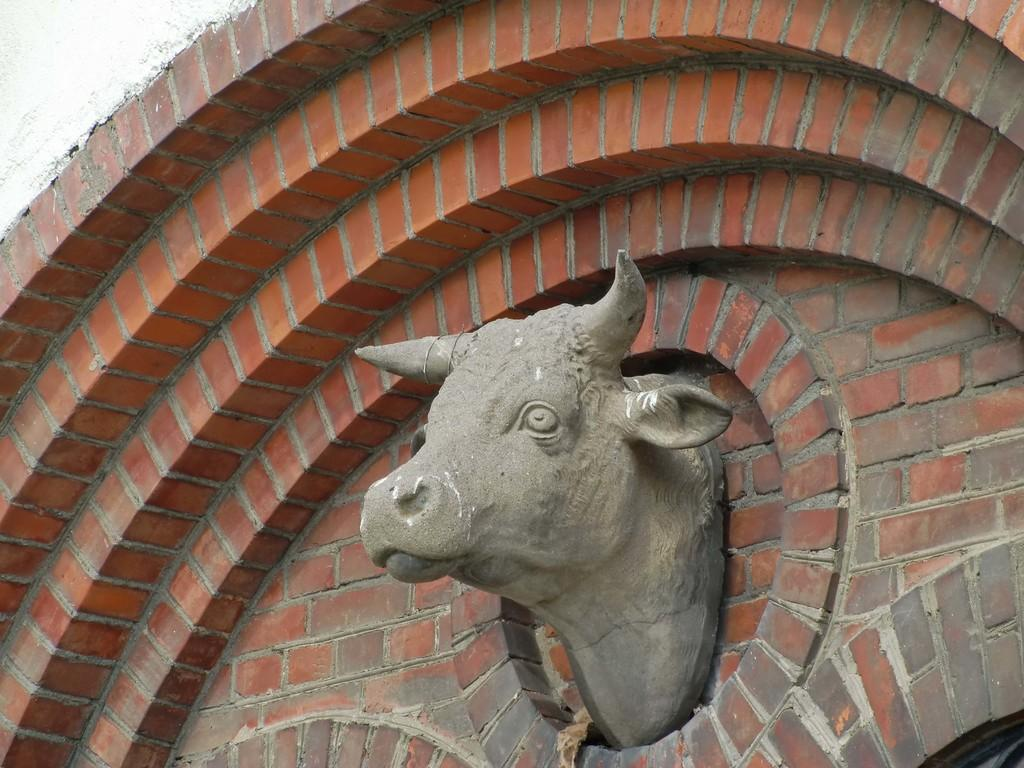What is the main subject of the image? The main subject of the image is a sculpture of a cow face. Where is the sculpture located? The sculpture is on a building. What color are the rings of jelly surrounding the cow sculpture in the image? There are no rings of jelly surrounding the cow sculpture in the image. 